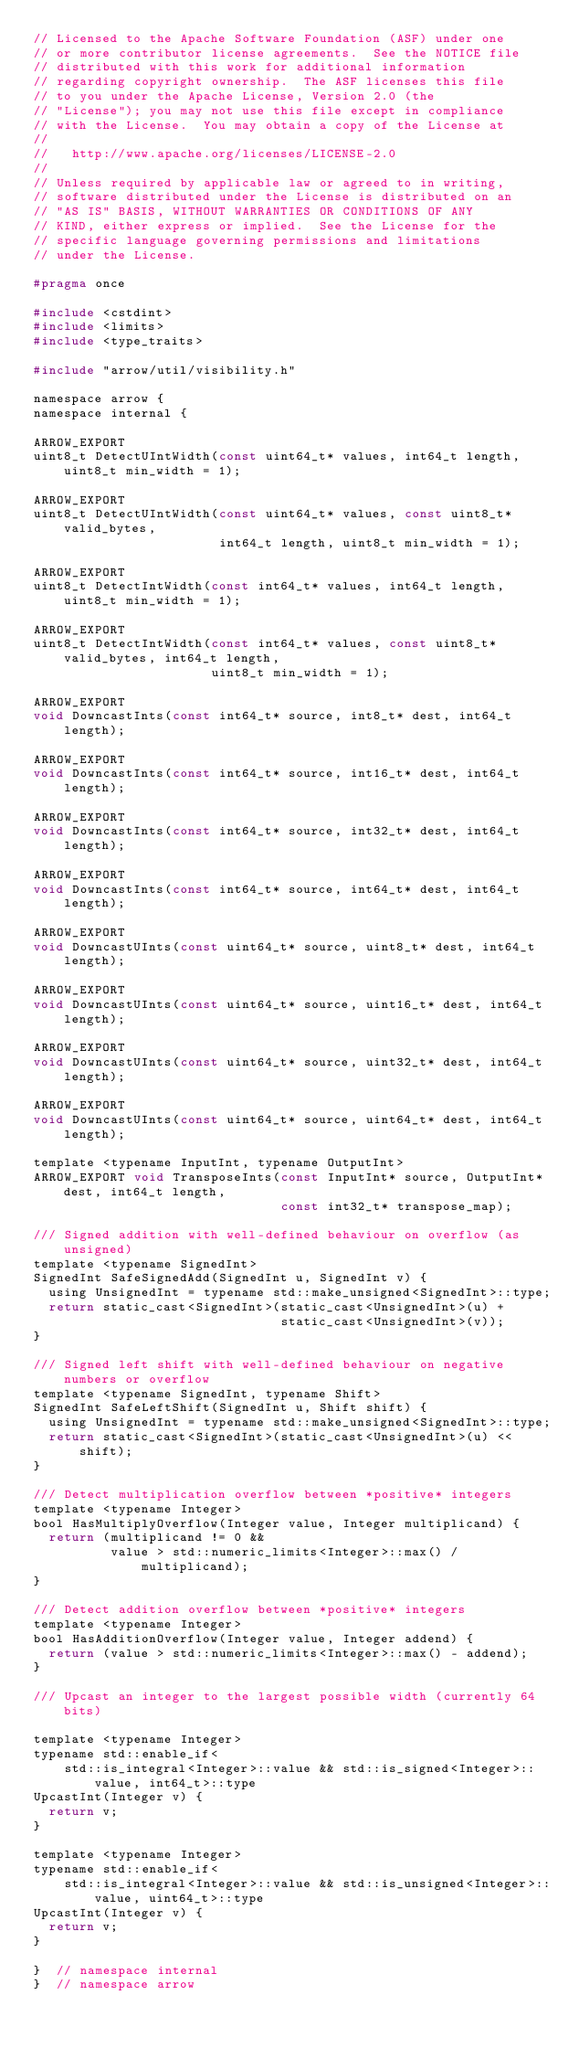Convert code to text. <code><loc_0><loc_0><loc_500><loc_500><_C_>// Licensed to the Apache Software Foundation (ASF) under one
// or more contributor license agreements.  See the NOTICE file
// distributed with this work for additional information
// regarding copyright ownership.  The ASF licenses this file
// to you under the Apache License, Version 2.0 (the
// "License"); you may not use this file except in compliance
// with the License.  You may obtain a copy of the License at
//
//   http://www.apache.org/licenses/LICENSE-2.0
//
// Unless required by applicable law or agreed to in writing,
// software distributed under the License is distributed on an
// "AS IS" BASIS, WITHOUT WARRANTIES OR CONDITIONS OF ANY
// KIND, either express or implied.  See the License for the
// specific language governing permissions and limitations
// under the License.

#pragma once

#include <cstdint>
#include <limits>
#include <type_traits>

#include "arrow/util/visibility.h"

namespace arrow {
namespace internal {

ARROW_EXPORT
uint8_t DetectUIntWidth(const uint64_t* values, int64_t length, uint8_t min_width = 1);

ARROW_EXPORT
uint8_t DetectUIntWidth(const uint64_t* values, const uint8_t* valid_bytes,
                        int64_t length, uint8_t min_width = 1);

ARROW_EXPORT
uint8_t DetectIntWidth(const int64_t* values, int64_t length, uint8_t min_width = 1);

ARROW_EXPORT
uint8_t DetectIntWidth(const int64_t* values, const uint8_t* valid_bytes, int64_t length,
                       uint8_t min_width = 1);

ARROW_EXPORT
void DowncastInts(const int64_t* source, int8_t* dest, int64_t length);

ARROW_EXPORT
void DowncastInts(const int64_t* source, int16_t* dest, int64_t length);

ARROW_EXPORT
void DowncastInts(const int64_t* source, int32_t* dest, int64_t length);

ARROW_EXPORT
void DowncastInts(const int64_t* source, int64_t* dest, int64_t length);

ARROW_EXPORT
void DowncastUInts(const uint64_t* source, uint8_t* dest, int64_t length);

ARROW_EXPORT
void DowncastUInts(const uint64_t* source, uint16_t* dest, int64_t length);

ARROW_EXPORT
void DowncastUInts(const uint64_t* source, uint32_t* dest, int64_t length);

ARROW_EXPORT
void DowncastUInts(const uint64_t* source, uint64_t* dest, int64_t length);

template <typename InputInt, typename OutputInt>
ARROW_EXPORT void TransposeInts(const InputInt* source, OutputInt* dest, int64_t length,
                                const int32_t* transpose_map);

/// Signed addition with well-defined behaviour on overflow (as unsigned)
template <typename SignedInt>
SignedInt SafeSignedAdd(SignedInt u, SignedInt v) {
  using UnsignedInt = typename std::make_unsigned<SignedInt>::type;
  return static_cast<SignedInt>(static_cast<UnsignedInt>(u) +
                                static_cast<UnsignedInt>(v));
}

/// Signed left shift with well-defined behaviour on negative numbers or overflow
template <typename SignedInt, typename Shift>
SignedInt SafeLeftShift(SignedInt u, Shift shift) {
  using UnsignedInt = typename std::make_unsigned<SignedInt>::type;
  return static_cast<SignedInt>(static_cast<UnsignedInt>(u) << shift);
}

/// Detect multiplication overflow between *positive* integers
template <typename Integer>
bool HasMultiplyOverflow(Integer value, Integer multiplicand) {
  return (multiplicand != 0 &&
          value > std::numeric_limits<Integer>::max() / multiplicand);
}

/// Detect addition overflow between *positive* integers
template <typename Integer>
bool HasAdditionOverflow(Integer value, Integer addend) {
  return (value > std::numeric_limits<Integer>::max() - addend);
}

/// Upcast an integer to the largest possible width (currently 64 bits)

template <typename Integer>
typename std::enable_if<
    std::is_integral<Integer>::value && std::is_signed<Integer>::value, int64_t>::type
UpcastInt(Integer v) {
  return v;
}

template <typename Integer>
typename std::enable_if<
    std::is_integral<Integer>::value && std::is_unsigned<Integer>::value, uint64_t>::type
UpcastInt(Integer v) {
  return v;
}

}  // namespace internal
}  // namespace arrow
</code> 